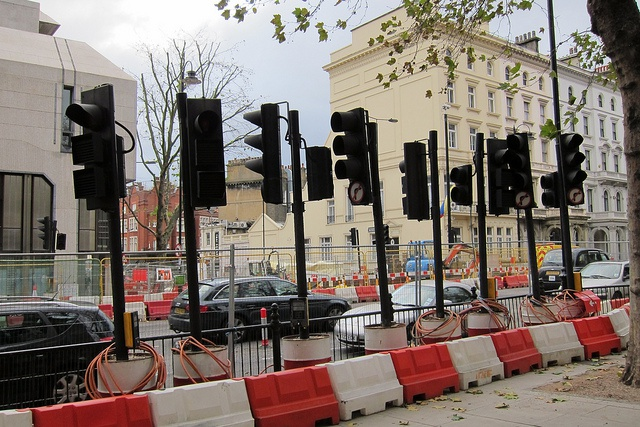Describe the objects in this image and their specific colors. I can see car in darkgray, black, gray, and maroon tones, car in darkgray, black, and gray tones, traffic light in darkgray, black, and gray tones, traffic light in darkgray, black, gray, and darkgreen tones, and traffic light in darkgray, black, gray, and lightgray tones in this image. 